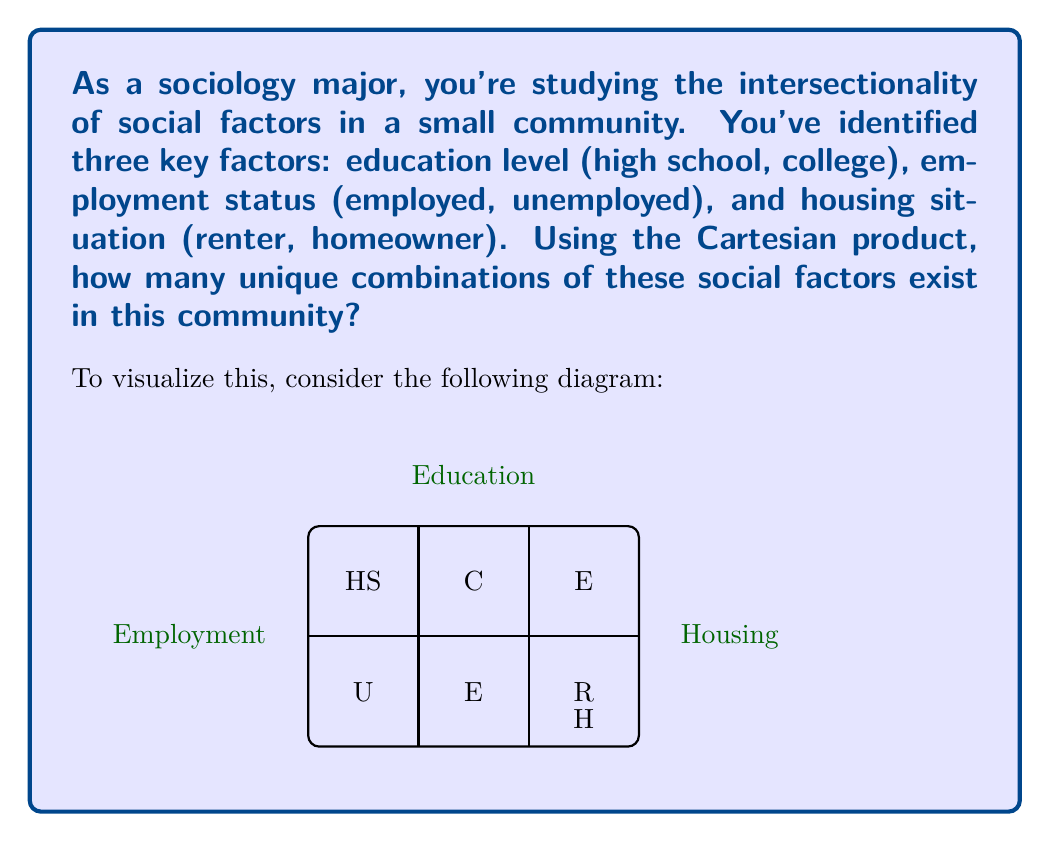Can you solve this math problem? To solve this problem, we need to use the concept of the Cartesian product in set theory. The Cartesian product of sets represents all possible combinations of elements from those sets.

Let's break it down step-by-step:

1) We have three sets:
   - Education level: $E = \{\text{high school, college}\}$
   - Employment status: $J = \{\text{employed, unemployed}\}$
   - Housing situation: $H = \{\text{renter, homeowner}\}$

2) The Cartesian product of these sets is denoted as $E \times J \times H$

3) To calculate the number of elements in the Cartesian product, we multiply the number of elements in each set:

   $|E \times J \times H| = |E| \cdot |J| \cdot |H|$

4) Counting the elements in each set:
   - $|E| = 2$ (high school, college)
   - $|J| = 2$ (employed, unemployed)
   - $|H| = 2$ (renter, homeowner)

5) Applying the formula:
   $|E \times J \times H| = 2 \cdot 2 \cdot 2 = 8$

Therefore, there are 8 unique combinations of these social factors in the community.

This approach demonstrates how intersectionality in sociology can be quantified using mathematical concepts, showing the interplay between different social factors.
Answer: 8 combinations 